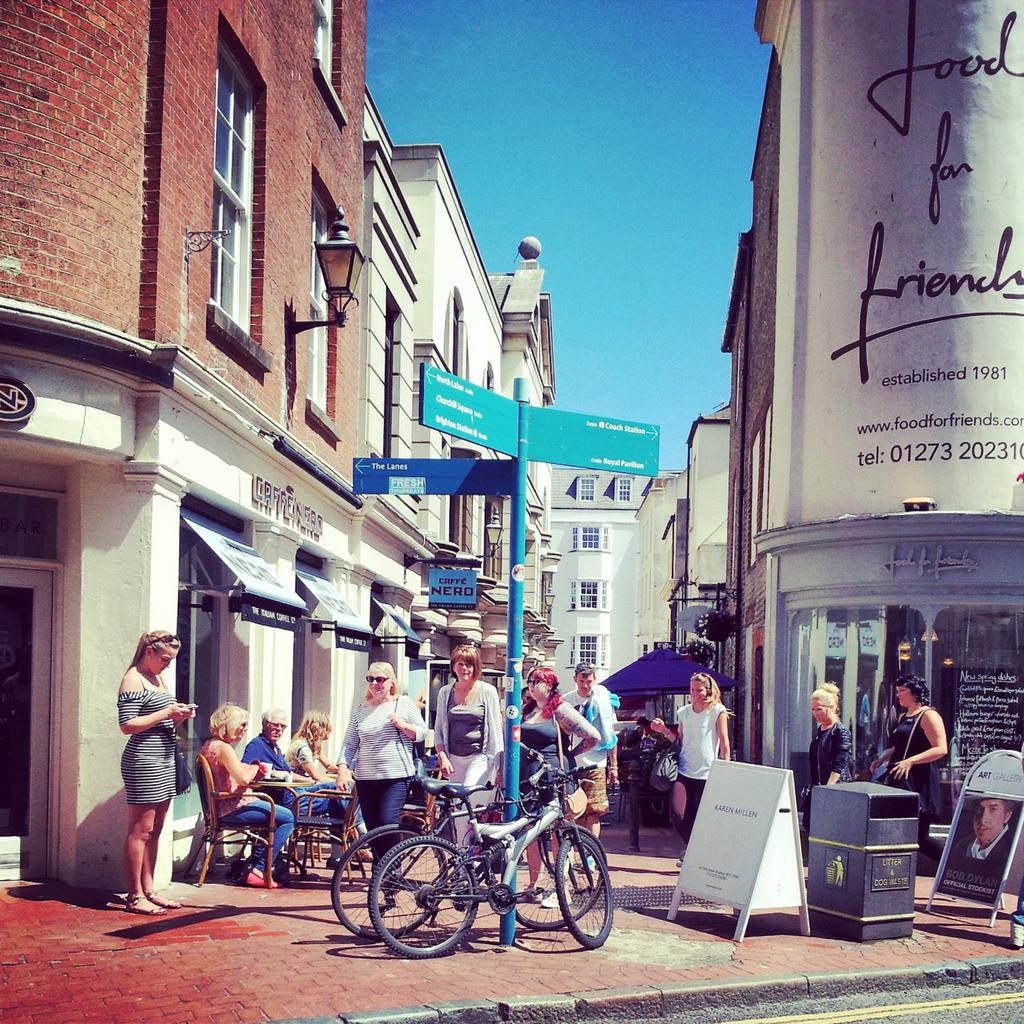What type of structures can be seen in the image? There are buildings in the image. Are there any people present in the image? Yes, there are people standing in the image. What can be seen near the pole in the image? There are bicycles beside a pole in the image. What type of container is present in the image? There is a bin in the image. What is located far in the image? There is a tent far in the image. What are some people doing in the image? There are people sitting on chairs in the image. Can you hear a whistle in the image? There is no mention of a whistle in the image, so it cannot be heard. What type of vest is being worn by the people in the image? There is no information about vests being worn by the people in the image. 